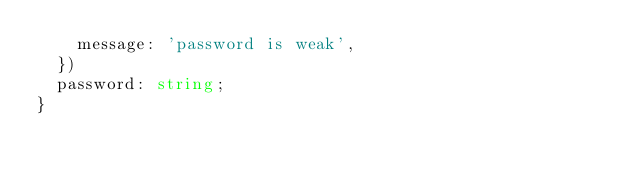<code> <loc_0><loc_0><loc_500><loc_500><_TypeScript_>    message: 'password is weak',
  })
  password: string;
}
</code> 